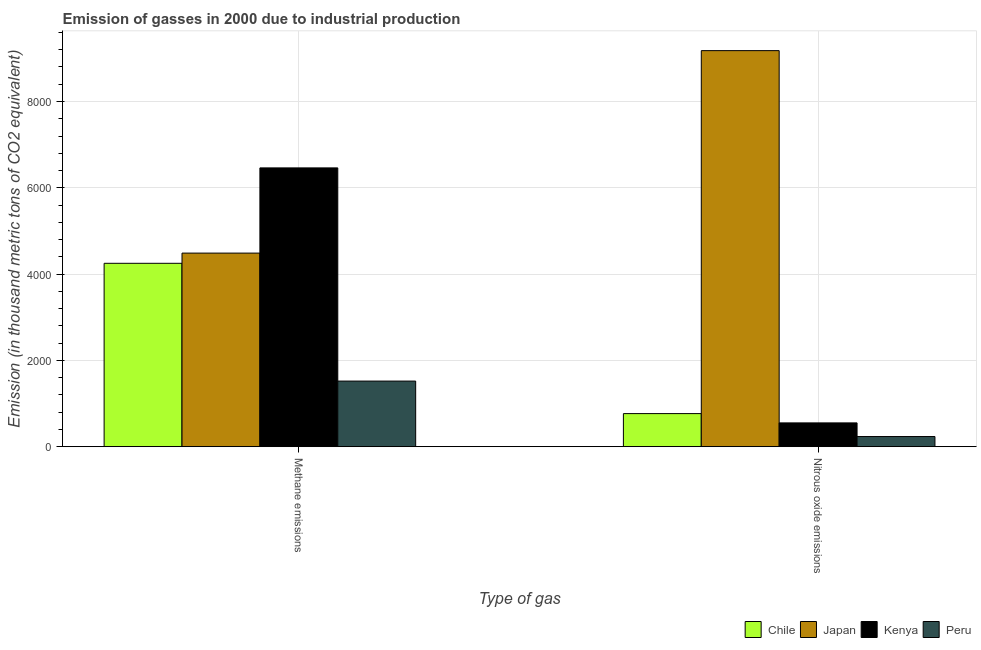How many groups of bars are there?
Your response must be concise. 2. Are the number of bars per tick equal to the number of legend labels?
Offer a terse response. Yes. Are the number of bars on each tick of the X-axis equal?
Provide a short and direct response. Yes. What is the label of the 1st group of bars from the left?
Your answer should be very brief. Methane emissions. What is the amount of nitrous oxide emissions in Japan?
Offer a very short reply. 9179.4. Across all countries, what is the maximum amount of methane emissions?
Your answer should be compact. 6461.4. Across all countries, what is the minimum amount of nitrous oxide emissions?
Your response must be concise. 235.2. In which country was the amount of methane emissions maximum?
Provide a succinct answer. Kenya. In which country was the amount of nitrous oxide emissions minimum?
Your answer should be very brief. Peru. What is the total amount of methane emissions in the graph?
Your answer should be compact. 1.67e+04. What is the difference between the amount of methane emissions in Chile and that in Peru?
Provide a succinct answer. 2729.7. What is the difference between the amount of methane emissions in Peru and the amount of nitrous oxide emissions in Chile?
Your answer should be compact. 753.6. What is the average amount of nitrous oxide emissions per country?
Your answer should be compact. 2683.25. What is the difference between the amount of nitrous oxide emissions and amount of methane emissions in Chile?
Offer a very short reply. -3483.3. In how many countries, is the amount of nitrous oxide emissions greater than 8800 thousand metric tons?
Your answer should be very brief. 1. What is the ratio of the amount of methane emissions in Chile to that in Kenya?
Provide a short and direct response. 0.66. Is the amount of nitrous oxide emissions in Japan less than that in Chile?
Make the answer very short. No. What does the 4th bar from the left in Methane emissions represents?
Offer a terse response. Peru. What does the 1st bar from the right in Nitrous oxide emissions represents?
Ensure brevity in your answer.  Peru. How many bars are there?
Ensure brevity in your answer.  8. Are all the bars in the graph horizontal?
Your answer should be compact. No. How many countries are there in the graph?
Offer a terse response. 4. Does the graph contain any zero values?
Provide a short and direct response. No. Where does the legend appear in the graph?
Ensure brevity in your answer.  Bottom right. How many legend labels are there?
Your answer should be compact. 4. How are the legend labels stacked?
Provide a short and direct response. Horizontal. What is the title of the graph?
Your answer should be very brief. Emission of gasses in 2000 due to industrial production. Does "St. Vincent and the Grenadines" appear as one of the legend labels in the graph?
Provide a short and direct response. No. What is the label or title of the X-axis?
Give a very brief answer. Type of gas. What is the label or title of the Y-axis?
Your answer should be compact. Emission (in thousand metric tons of CO2 equivalent). What is the Emission (in thousand metric tons of CO2 equivalent) in Chile in Methane emissions?
Provide a short and direct response. 4250.2. What is the Emission (in thousand metric tons of CO2 equivalent) in Japan in Methane emissions?
Offer a very short reply. 4486.9. What is the Emission (in thousand metric tons of CO2 equivalent) of Kenya in Methane emissions?
Keep it short and to the point. 6461.4. What is the Emission (in thousand metric tons of CO2 equivalent) in Peru in Methane emissions?
Provide a short and direct response. 1520.5. What is the Emission (in thousand metric tons of CO2 equivalent) in Chile in Nitrous oxide emissions?
Keep it short and to the point. 766.9. What is the Emission (in thousand metric tons of CO2 equivalent) of Japan in Nitrous oxide emissions?
Your response must be concise. 9179.4. What is the Emission (in thousand metric tons of CO2 equivalent) in Kenya in Nitrous oxide emissions?
Keep it short and to the point. 551.5. What is the Emission (in thousand metric tons of CO2 equivalent) in Peru in Nitrous oxide emissions?
Make the answer very short. 235.2. Across all Type of gas, what is the maximum Emission (in thousand metric tons of CO2 equivalent) of Chile?
Provide a succinct answer. 4250.2. Across all Type of gas, what is the maximum Emission (in thousand metric tons of CO2 equivalent) of Japan?
Offer a terse response. 9179.4. Across all Type of gas, what is the maximum Emission (in thousand metric tons of CO2 equivalent) of Kenya?
Keep it short and to the point. 6461.4. Across all Type of gas, what is the maximum Emission (in thousand metric tons of CO2 equivalent) of Peru?
Your answer should be compact. 1520.5. Across all Type of gas, what is the minimum Emission (in thousand metric tons of CO2 equivalent) of Chile?
Ensure brevity in your answer.  766.9. Across all Type of gas, what is the minimum Emission (in thousand metric tons of CO2 equivalent) of Japan?
Your response must be concise. 4486.9. Across all Type of gas, what is the minimum Emission (in thousand metric tons of CO2 equivalent) of Kenya?
Your answer should be very brief. 551.5. Across all Type of gas, what is the minimum Emission (in thousand metric tons of CO2 equivalent) of Peru?
Provide a succinct answer. 235.2. What is the total Emission (in thousand metric tons of CO2 equivalent) of Chile in the graph?
Provide a short and direct response. 5017.1. What is the total Emission (in thousand metric tons of CO2 equivalent) in Japan in the graph?
Give a very brief answer. 1.37e+04. What is the total Emission (in thousand metric tons of CO2 equivalent) of Kenya in the graph?
Give a very brief answer. 7012.9. What is the total Emission (in thousand metric tons of CO2 equivalent) in Peru in the graph?
Make the answer very short. 1755.7. What is the difference between the Emission (in thousand metric tons of CO2 equivalent) of Chile in Methane emissions and that in Nitrous oxide emissions?
Your answer should be compact. 3483.3. What is the difference between the Emission (in thousand metric tons of CO2 equivalent) in Japan in Methane emissions and that in Nitrous oxide emissions?
Your answer should be compact. -4692.5. What is the difference between the Emission (in thousand metric tons of CO2 equivalent) in Kenya in Methane emissions and that in Nitrous oxide emissions?
Provide a short and direct response. 5909.9. What is the difference between the Emission (in thousand metric tons of CO2 equivalent) of Peru in Methane emissions and that in Nitrous oxide emissions?
Ensure brevity in your answer.  1285.3. What is the difference between the Emission (in thousand metric tons of CO2 equivalent) in Chile in Methane emissions and the Emission (in thousand metric tons of CO2 equivalent) in Japan in Nitrous oxide emissions?
Make the answer very short. -4929.2. What is the difference between the Emission (in thousand metric tons of CO2 equivalent) of Chile in Methane emissions and the Emission (in thousand metric tons of CO2 equivalent) of Kenya in Nitrous oxide emissions?
Make the answer very short. 3698.7. What is the difference between the Emission (in thousand metric tons of CO2 equivalent) of Chile in Methane emissions and the Emission (in thousand metric tons of CO2 equivalent) of Peru in Nitrous oxide emissions?
Keep it short and to the point. 4015. What is the difference between the Emission (in thousand metric tons of CO2 equivalent) in Japan in Methane emissions and the Emission (in thousand metric tons of CO2 equivalent) in Kenya in Nitrous oxide emissions?
Keep it short and to the point. 3935.4. What is the difference between the Emission (in thousand metric tons of CO2 equivalent) of Japan in Methane emissions and the Emission (in thousand metric tons of CO2 equivalent) of Peru in Nitrous oxide emissions?
Offer a very short reply. 4251.7. What is the difference between the Emission (in thousand metric tons of CO2 equivalent) of Kenya in Methane emissions and the Emission (in thousand metric tons of CO2 equivalent) of Peru in Nitrous oxide emissions?
Ensure brevity in your answer.  6226.2. What is the average Emission (in thousand metric tons of CO2 equivalent) in Chile per Type of gas?
Give a very brief answer. 2508.55. What is the average Emission (in thousand metric tons of CO2 equivalent) of Japan per Type of gas?
Keep it short and to the point. 6833.15. What is the average Emission (in thousand metric tons of CO2 equivalent) in Kenya per Type of gas?
Offer a terse response. 3506.45. What is the average Emission (in thousand metric tons of CO2 equivalent) of Peru per Type of gas?
Your answer should be very brief. 877.85. What is the difference between the Emission (in thousand metric tons of CO2 equivalent) in Chile and Emission (in thousand metric tons of CO2 equivalent) in Japan in Methane emissions?
Your answer should be compact. -236.7. What is the difference between the Emission (in thousand metric tons of CO2 equivalent) in Chile and Emission (in thousand metric tons of CO2 equivalent) in Kenya in Methane emissions?
Your answer should be compact. -2211.2. What is the difference between the Emission (in thousand metric tons of CO2 equivalent) in Chile and Emission (in thousand metric tons of CO2 equivalent) in Peru in Methane emissions?
Your answer should be very brief. 2729.7. What is the difference between the Emission (in thousand metric tons of CO2 equivalent) in Japan and Emission (in thousand metric tons of CO2 equivalent) in Kenya in Methane emissions?
Ensure brevity in your answer.  -1974.5. What is the difference between the Emission (in thousand metric tons of CO2 equivalent) of Japan and Emission (in thousand metric tons of CO2 equivalent) of Peru in Methane emissions?
Make the answer very short. 2966.4. What is the difference between the Emission (in thousand metric tons of CO2 equivalent) in Kenya and Emission (in thousand metric tons of CO2 equivalent) in Peru in Methane emissions?
Your response must be concise. 4940.9. What is the difference between the Emission (in thousand metric tons of CO2 equivalent) of Chile and Emission (in thousand metric tons of CO2 equivalent) of Japan in Nitrous oxide emissions?
Make the answer very short. -8412.5. What is the difference between the Emission (in thousand metric tons of CO2 equivalent) of Chile and Emission (in thousand metric tons of CO2 equivalent) of Kenya in Nitrous oxide emissions?
Your response must be concise. 215.4. What is the difference between the Emission (in thousand metric tons of CO2 equivalent) of Chile and Emission (in thousand metric tons of CO2 equivalent) of Peru in Nitrous oxide emissions?
Your response must be concise. 531.7. What is the difference between the Emission (in thousand metric tons of CO2 equivalent) of Japan and Emission (in thousand metric tons of CO2 equivalent) of Kenya in Nitrous oxide emissions?
Your answer should be very brief. 8627.9. What is the difference between the Emission (in thousand metric tons of CO2 equivalent) of Japan and Emission (in thousand metric tons of CO2 equivalent) of Peru in Nitrous oxide emissions?
Your answer should be very brief. 8944.2. What is the difference between the Emission (in thousand metric tons of CO2 equivalent) in Kenya and Emission (in thousand metric tons of CO2 equivalent) in Peru in Nitrous oxide emissions?
Ensure brevity in your answer.  316.3. What is the ratio of the Emission (in thousand metric tons of CO2 equivalent) in Chile in Methane emissions to that in Nitrous oxide emissions?
Give a very brief answer. 5.54. What is the ratio of the Emission (in thousand metric tons of CO2 equivalent) in Japan in Methane emissions to that in Nitrous oxide emissions?
Offer a terse response. 0.49. What is the ratio of the Emission (in thousand metric tons of CO2 equivalent) of Kenya in Methane emissions to that in Nitrous oxide emissions?
Make the answer very short. 11.72. What is the ratio of the Emission (in thousand metric tons of CO2 equivalent) in Peru in Methane emissions to that in Nitrous oxide emissions?
Keep it short and to the point. 6.46. What is the difference between the highest and the second highest Emission (in thousand metric tons of CO2 equivalent) of Chile?
Offer a very short reply. 3483.3. What is the difference between the highest and the second highest Emission (in thousand metric tons of CO2 equivalent) of Japan?
Ensure brevity in your answer.  4692.5. What is the difference between the highest and the second highest Emission (in thousand metric tons of CO2 equivalent) of Kenya?
Ensure brevity in your answer.  5909.9. What is the difference between the highest and the second highest Emission (in thousand metric tons of CO2 equivalent) of Peru?
Your answer should be compact. 1285.3. What is the difference between the highest and the lowest Emission (in thousand metric tons of CO2 equivalent) in Chile?
Make the answer very short. 3483.3. What is the difference between the highest and the lowest Emission (in thousand metric tons of CO2 equivalent) in Japan?
Your answer should be very brief. 4692.5. What is the difference between the highest and the lowest Emission (in thousand metric tons of CO2 equivalent) of Kenya?
Make the answer very short. 5909.9. What is the difference between the highest and the lowest Emission (in thousand metric tons of CO2 equivalent) of Peru?
Give a very brief answer. 1285.3. 